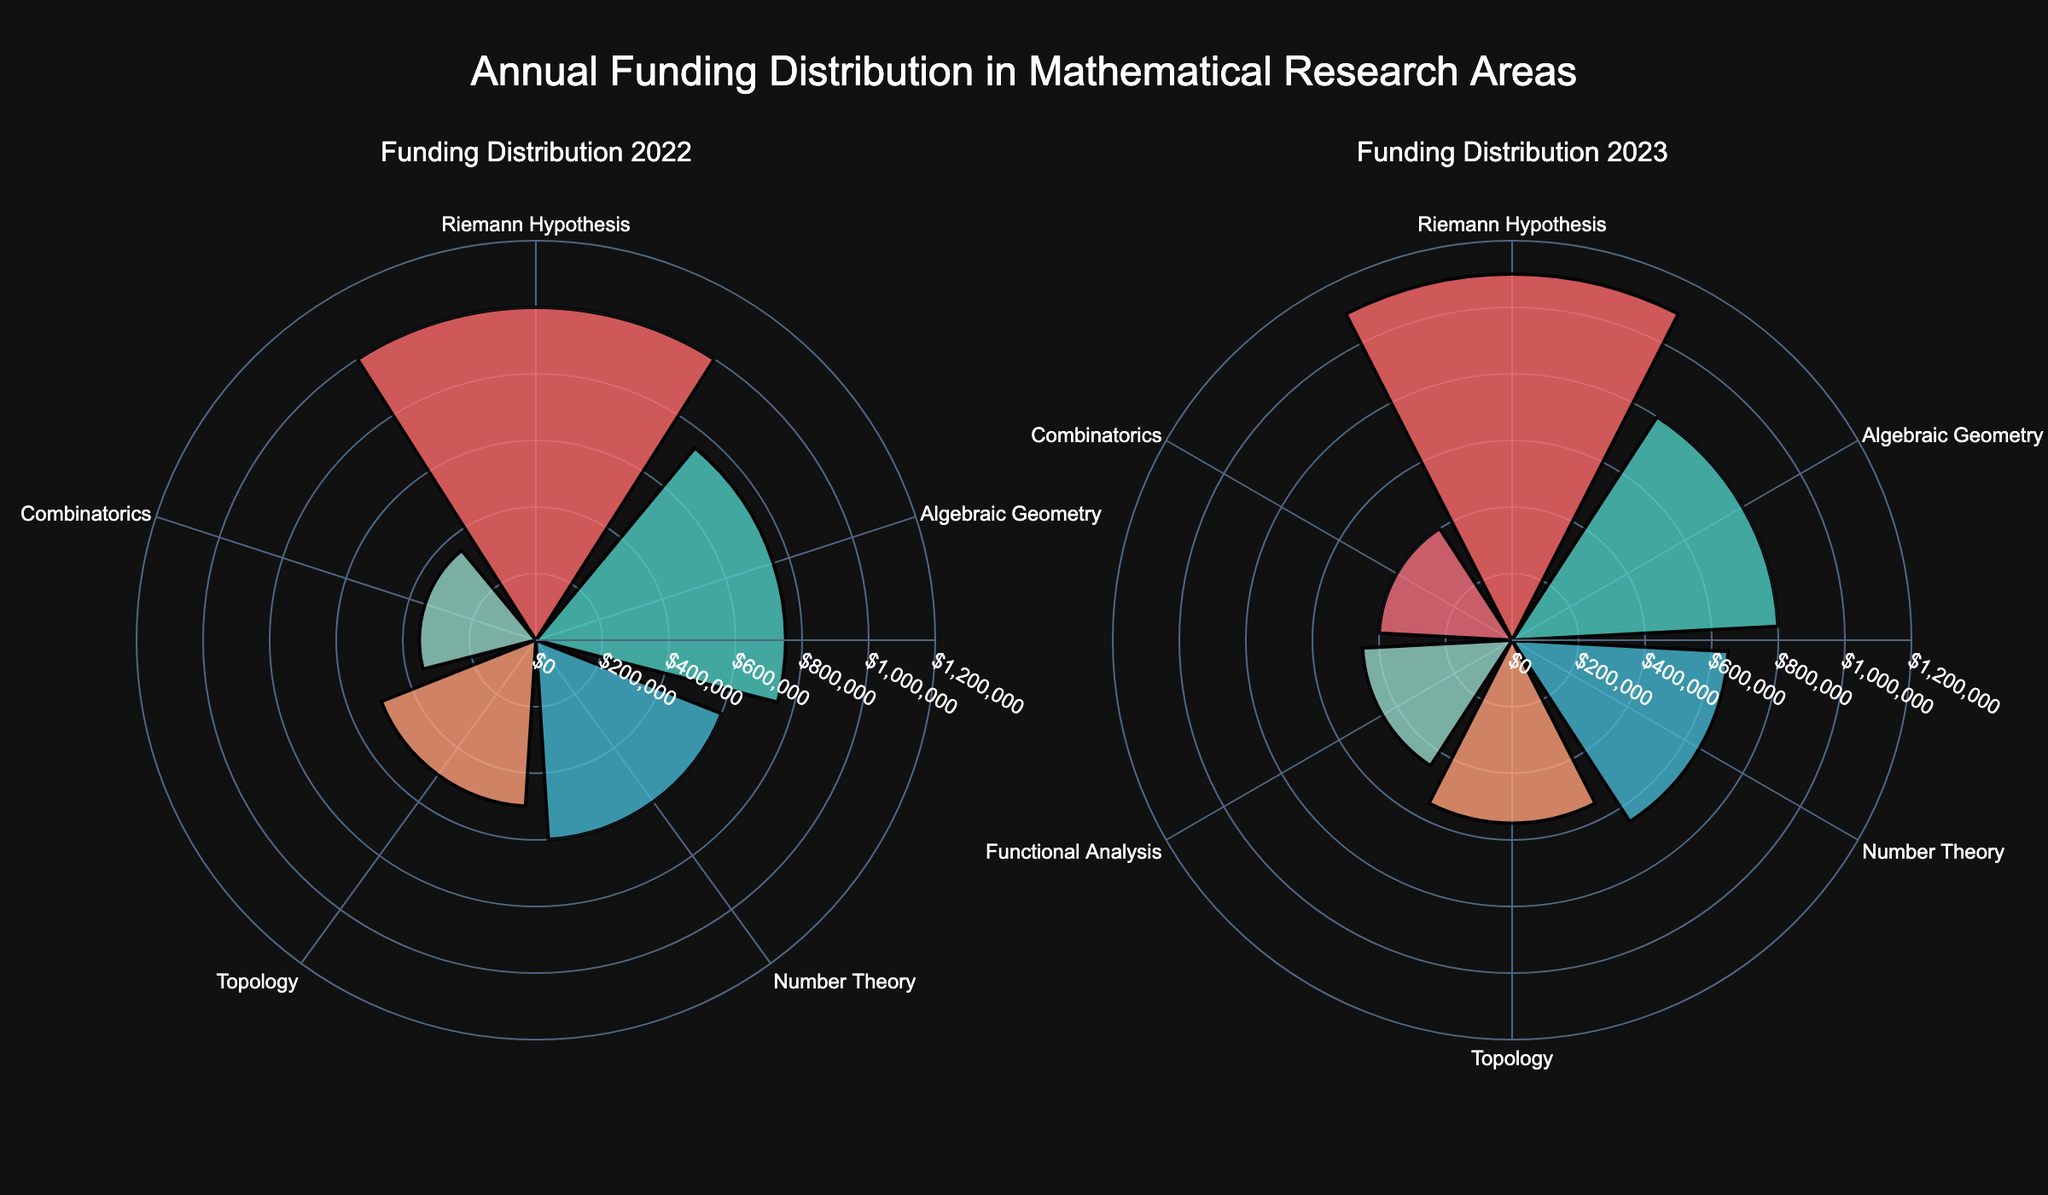what are the mathematical areas shown in the plot for the year 2022? The subplot for 2022 shows rose chart sections labeled by the mathematical areas. From the figure, we can identify the names of different areas by looking at the labels around the chart.
Answer: Riemann Hypothesis, Algebraic Geometry, Number Theory, Topology, Combinatorics Which mathematical area received the highest funding in 2023? The height or the maximum radius for each section in the 2023 subplot represents the funding amount. By comparing these, the longest section indicates the highest funding. The longest radius points to "Riemann Hypothesis".
Answer: Riemann Hypothesis How does the funding for Algebraic Geometry in 2023 compare to 2022? To compare the funding for Algebraic Geometry between 2022 and 2023, look at the lengths of the corresponding sections in both subplots. The 2023 section is slightly longer than the one in 2022. This shows an increase in funding.
Answer: Increased What is the approximate funding difference between Riemann Hypothesis and Number Theory in 2022? Measure the length of the sections for Riemann Hypothesis and Number Theory in the 2022 subplot. The funding for Riemann Hypothesis is around $1,000,000 and for Number Theory is around $600,000. The difference is about $400,000.
Answer: $400,000 Which mathematical area had the least funding in 2023? By examining the shortest section in the 2023 subplot, the area with the least funding can be identified. The shortest section belongs to "Combinatorics".
Answer: Combinatorics In which year did Topology receive more funding? Compare the lengths of the Topology section in the subplots for 2022 and 2023. The 2023 section is slightly longer, indicating a higher funding amount.
Answer: 2023 Calculate the total funding for all areas in 2022. Sum the funding amounts for each mathematical area from the 2022 subplot. The amounts are $1,000,000 (Riemann Hypothesis) + $750,000 (Algebraic Geometry) + $600,000 (Number Theory) + $500,000 (Topology) + $350,000 (Combinatorics) = $3,200,000.
Answer: $3,200,000 Which institution supports Riemann Hypothesis research, and how can you tell? The rose chart does not directly show institution names, but one can infer from the funding patterns and typical knowledge about research institutions. Clay Mathematics Institute is known to support Riemann Hypothesis work.
Answer: Clay Mathematics Institute 